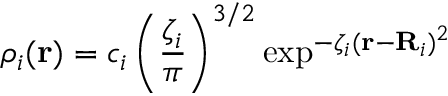Convert formula to latex. <formula><loc_0><loc_0><loc_500><loc_500>\rho _ { i } ( r ) = c _ { i } \left ( \frac { \zeta _ { i } } { \pi } \right ) ^ { 3 / 2 } \exp ^ { - \zeta _ { i } ( r - R _ { i } ) ^ { 2 } }</formula> 